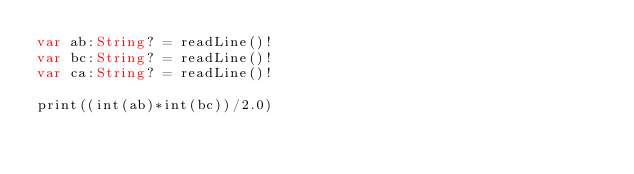<code> <loc_0><loc_0><loc_500><loc_500><_Swift_>var ab:String? = readLine()!
var bc:String? = readLine()!
var ca:String? = readLine()!

print((int(ab)*int(bc))/2.0)
</code> 